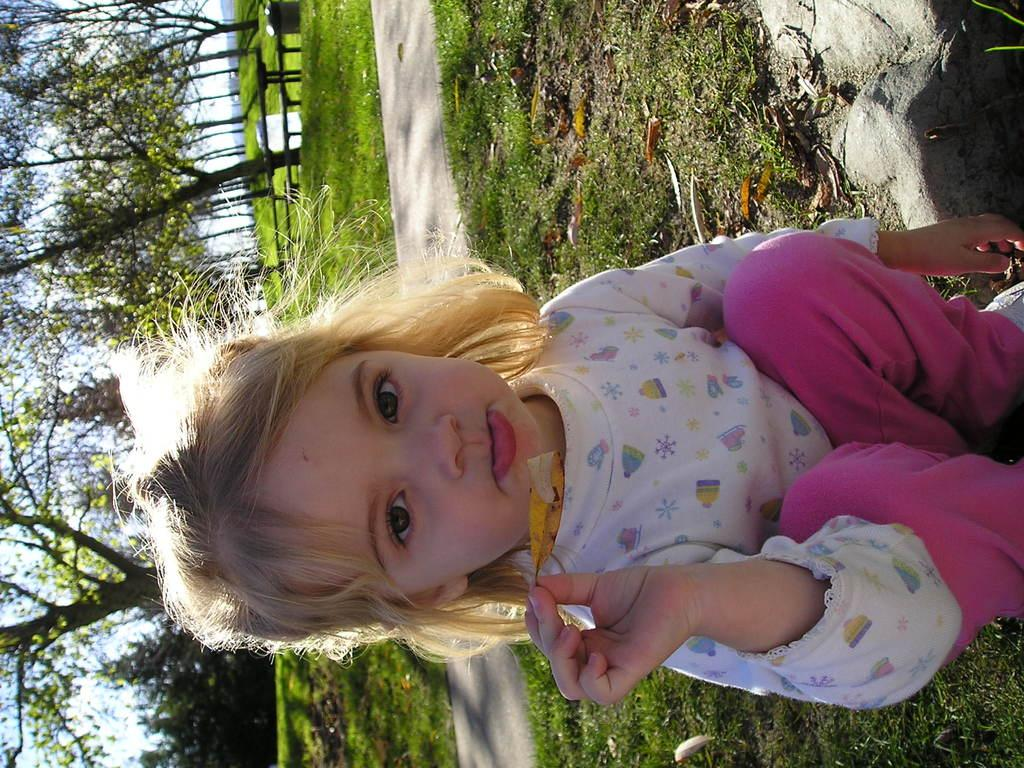What is the child doing in the image? The child is sitting on the ground in the image. What type of natural material is present in the image? Shredded leaves are present in the image. What type of geological formation is visible in the image? Rocks are visible in the image. What type of man-made structure can be seen in the image? There is a road in the image. What type of barrier is present in the image? A wooden fence is present in the image. What type of vegetation is visible in the image? Trees are visible in the image. What part of the natural environment is visible in the image? The sky is visible in the image. What type of grape is the child eating in the image? There is no grape present in the image, and the child is not eating anything. What type of clothing is the child wearing in the image? The provided facts do not mention any clothing, so we cannot definitively answer this question. 